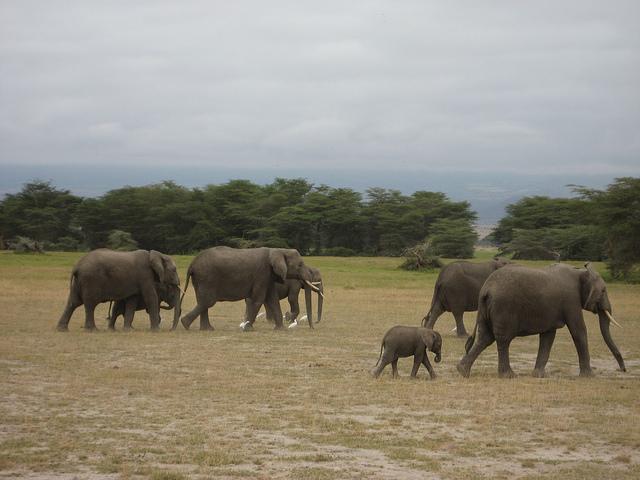How many animals are there?
Give a very brief answer. 5. Who would the smallest animal be following?
Be succinct. Mother. What species of elephant is in the photo?
Be succinct. African. How many elephants are in the image?
Give a very brief answer. 7. 